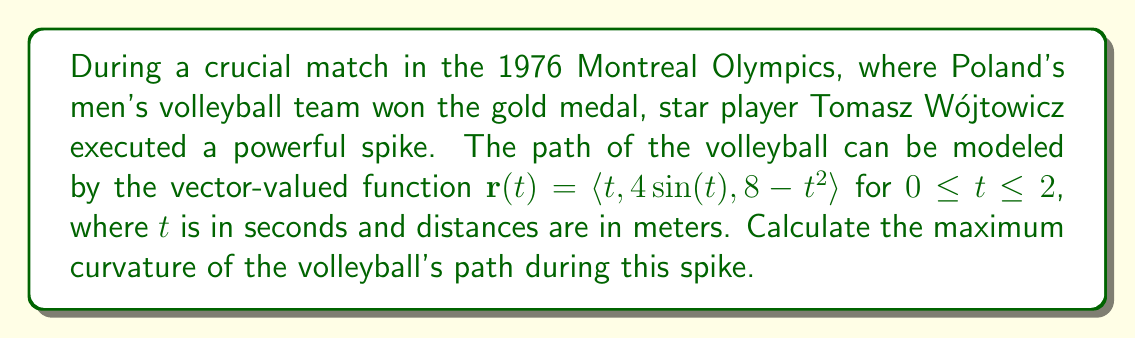Can you answer this question? To find the maximum curvature, we'll follow these steps:

1) The curvature formula for a vector-valued function is:

   $$\kappa = \frac{|\mathbf{r}'(t) \times \mathbf{r}''(t)|}{|\mathbf{r}'(t)|^3}$$

2) Calculate $\mathbf{r}'(t)$:
   $$\mathbf{r}'(t) = \langle 1, 4\cos(t), -2t \rangle$$

3) Calculate $\mathbf{r}''(t)$:
   $$\mathbf{r}''(t) = \langle 0, -4\sin(t), -2 \rangle$$

4) Calculate $\mathbf{r}'(t) \times \mathbf{r}''(t)$:
   $$\mathbf{r}'(t) \times \mathbf{r}''(t) = \langle 8\cos(t)-8t\sin(t), 2, -4\sin(t) \rangle$$

5) Calculate $|\mathbf{r}'(t) \times \mathbf{r}''(t)|$:
   $$|\mathbf{r}'(t) \times \mathbf{r}''(t)| = \sqrt{(8\cos(t)-8t\sin(t))^2 + 4 + 16\sin^2(t)}$$

6) Calculate $|\mathbf{r}'(t)|$:
   $$|\mathbf{r}'(t)| = \sqrt{1 + 16\cos^2(t) + 4t^2}$$

7) The curvature function is:
   $$\kappa(t) = \frac{\sqrt{(8\cos(t)-8t\sin(t))^2 + 4 + 16\sin^2(t)}}{(1 + 16\cos^2(t) + 4t^2)^{3/2}}$$

8) To find the maximum curvature, we need to find the maximum value of $\kappa(t)$ on the interval $[0,2]$. This can be done by differentiating $\kappa(t)$, setting it to zero, and solving for t. However, the resulting equation is very complex.

9) As an alternative, we can use numerical methods to approximate the maximum value. Plotting $\kappa(t)$ or using a computer algebra system reveals that the maximum occurs near $t=0$.

10) Evaluating $\kappa(0)$:
    $$\kappa(0) = \frac{\sqrt{64 + 4}}{(1 + 16)^{3/2}} = \frac{\sqrt{68}}{17^{3/2}} \approx 0.2834$$

This is the maximum curvature of the volleyball's path during Wójtowicz's spike.
Answer: $\frac{\sqrt{68}}{17^{3/2}} \approx 0.2834$ m^(-1) 